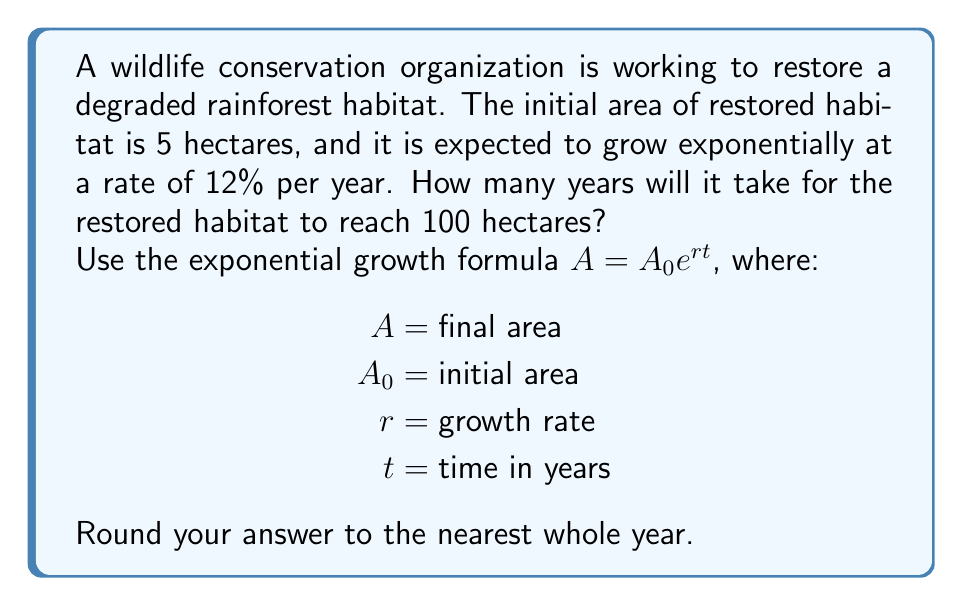Can you solve this math problem? Let's approach this step-by-step:

1) We're given:
   $A_0 = 5$ hectares (initial area)
   $r = 0.12$ (12% annual growth rate)
   $A = 100$ hectares (target area)

2) We need to solve for $t$ in the equation:
   $A = A_0e^{rt}$

3) Substituting our known values:
   $100 = 5e^{0.12t}$

4) Divide both sides by 5:
   $20 = e^{0.12t}$

5) Take the natural log of both sides:
   $\ln(20) = \ln(e^{0.12t})$

6) Simplify the right side using the property of logarithms:
   $\ln(20) = 0.12t$

7) Solve for $t$:
   $t = \frac{\ln(20)}{0.12}$

8) Calculate:
   $t = \frac{2.9957}{0.12} \approx 24.9642$ years

9) Rounding to the nearest whole year:
   $t \approx 25$ years
Answer: 25 years 